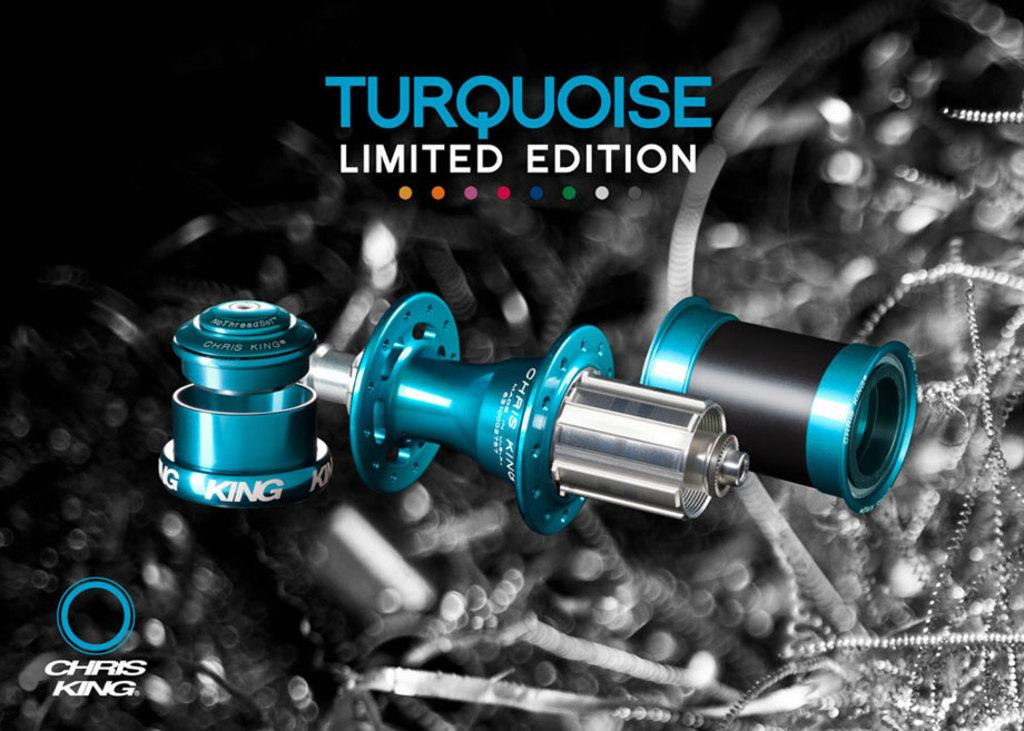What can be observed about the image's appearance? The image appears to be edited. What type of object is featured in the image? The image contains parts of a vehicle. Are there any textual elements in the image? Yes, there are letters visible in the image. What type of symbol is present in the image? A logo is present in the image. What can be seen in terms of visual design in the image? There is a design in the image. What type of noise can be heard coming from the vehicle in the image? There is no sound present in the image, so it is not possible to determine what noise might be heard. 